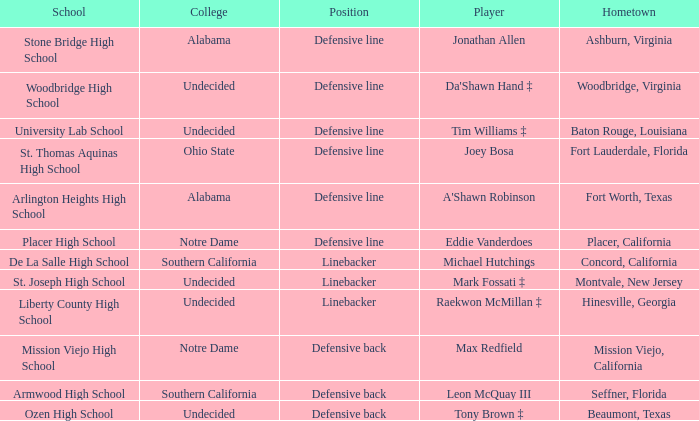What is the position of the player from Beaumont, Texas? Defensive back. 